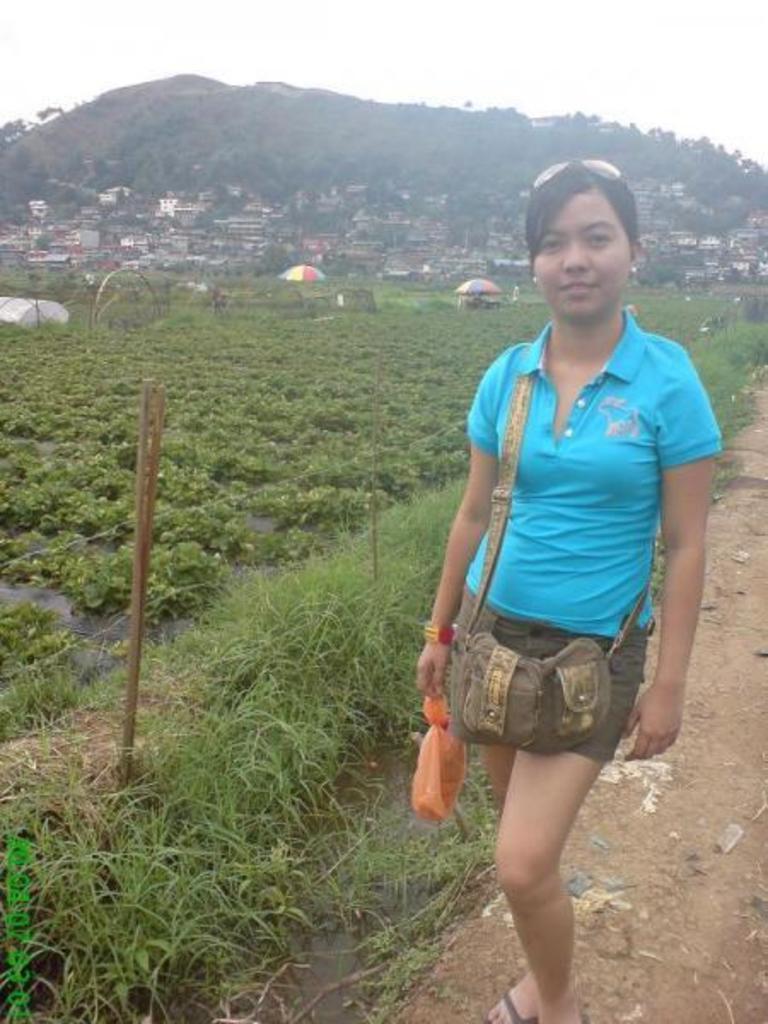Describe this image in one or two sentences. In this picture I can see there is a woman standing and she is wearing a bag, holding a carry bag in the right hand, there is some soil to the right side and there is grass, a fence on left side, there are few plants on the left side. In the backdrop, there are a few buildings and trees, there is a mountain and the sky is clear. 